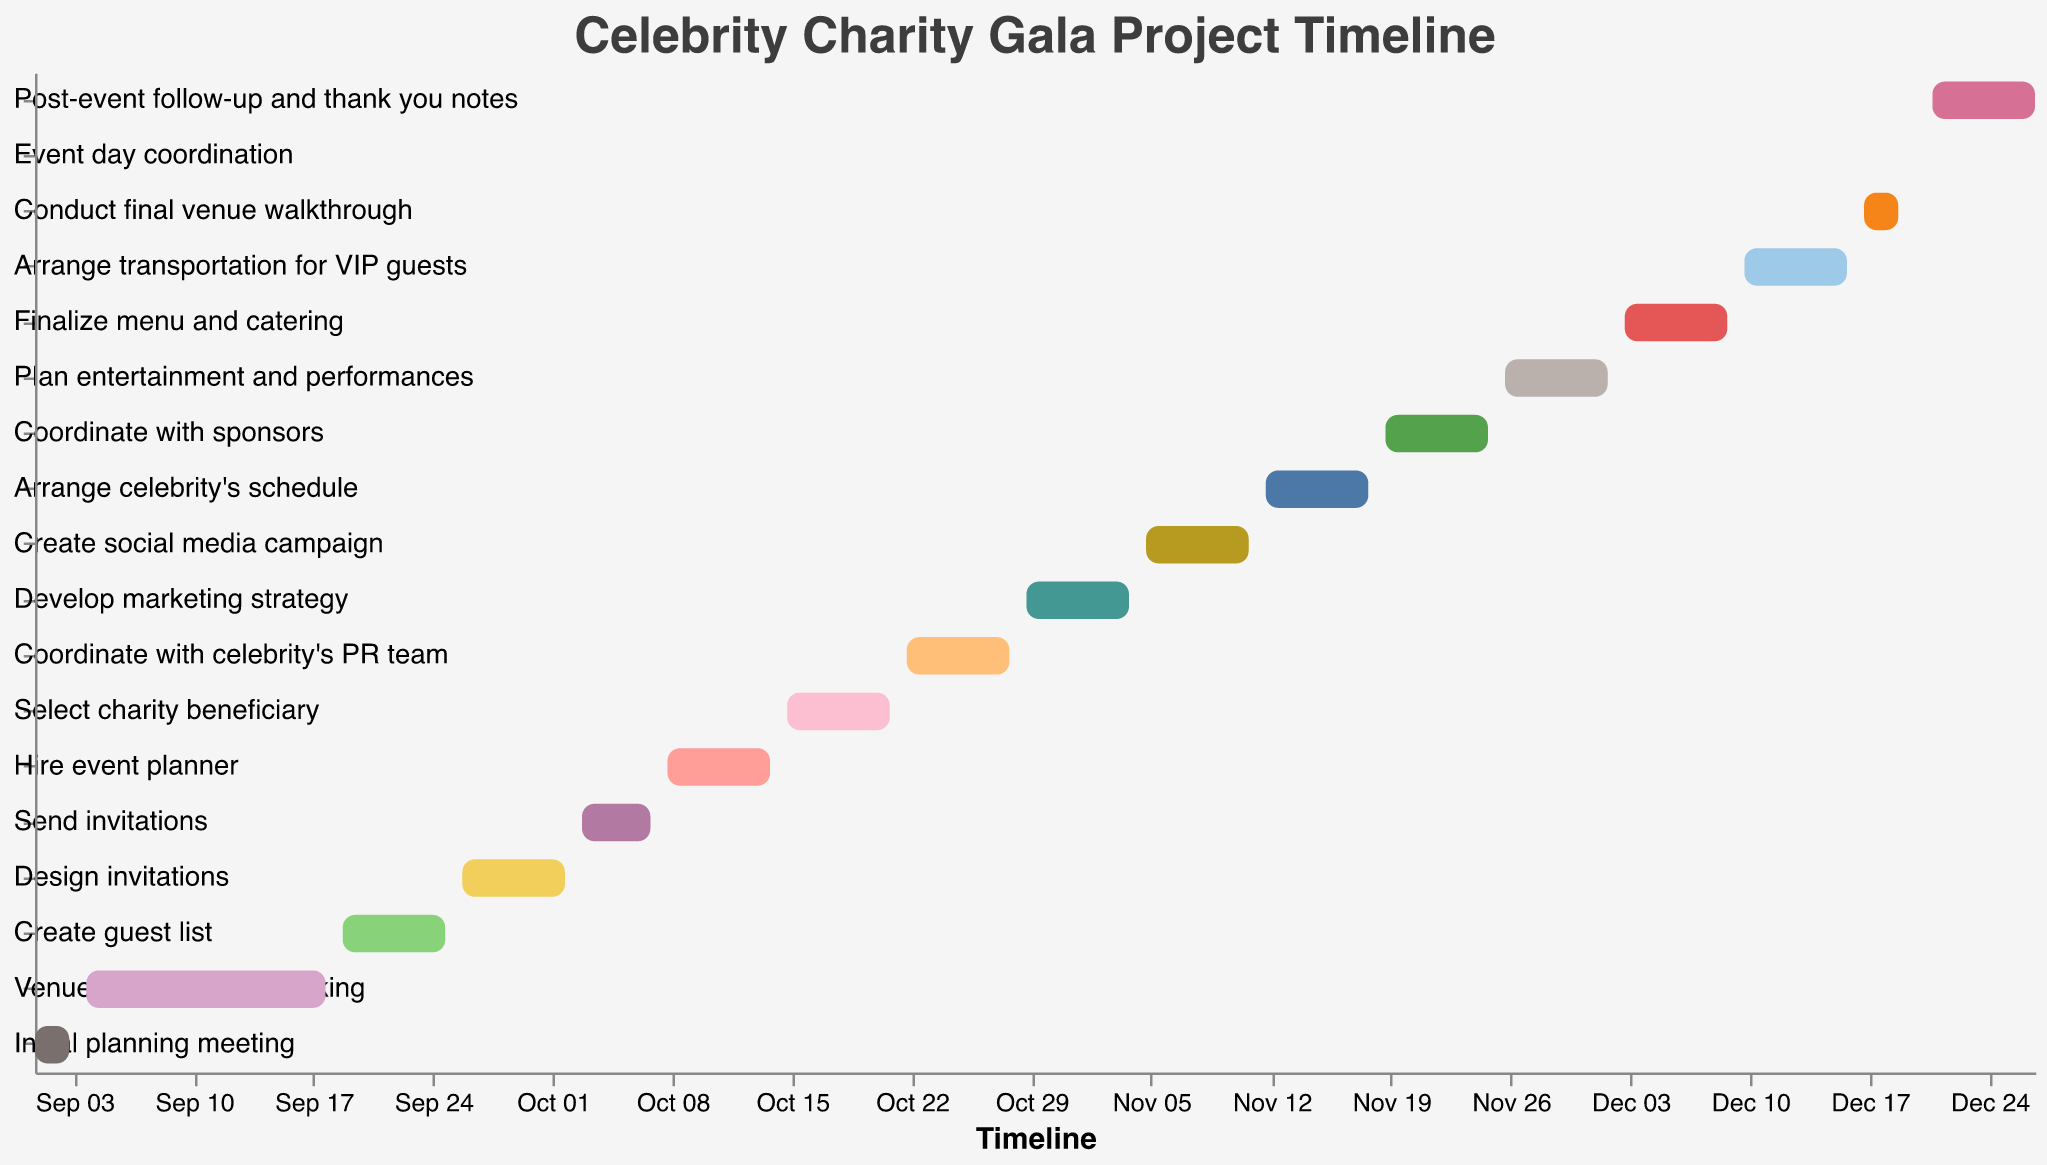What's the title of the chart? The title of the chart is typically found at the top of the figure and it summarises the purpose or content of the chart. In this case, the title is "Celebrity Charity Gala Project Timeline".
Answer: Celebrity Charity Gala Project Timeline How long does the "Venue selection and booking" task take? To determine the duration of the "Venue selection and booking" task, subtract the start date (2023-09-04) from the end date (2023-09-18). The difference is 14 days.
Answer: 14 days Which task starts first, "Create guest list" or "Design invitations"? By comparing the start dates of "Create guest list" (2023-09-19) and "Design invitations" (2023-09-26), it's evident that "Create guest list" starts first.
Answer: Create guest list What is the last task on the chart? The last task is determined by looking at the end dates of all tasks. The task "Post-event follow-up and thank you notes" ends on 2023-12-27, making it the last task.
Answer: Post-event follow-up and thank you notes During which month does the "Develop marketing strategy" task occur? The start date of the "Develop marketing strategy" task is 2023-10-29 and the end date is 2023-11-04. Both dates fall within October and November.
Answer: October and November Which tasks overlap with "Hire event planner"? To identify overlapping tasks, compare the duration of "Hire event planner" (2023-10-08 to 2023-10-14) with other tasks' durations. "Send invitations" (2023-10-03 to 2023-10-07) and "Select charity beneficiary" (2023-10-15 to 2023-10-21) slightly overlap with "Hire event planner".
Answer: None Name two tasks that happen solely in December. By examining tasks with both start and end dates in December, the tasks "Finalize menu and catering" (2023-12-03 to 2023-12-09) and "Arrange transportation for VIP guests" (2023-12-10 to 2023-12-16) are solely in December.
Answer: Finalize menu and catering, Arrange transportation for VIP guests Which phase has the most number of tasks? (Planning, Promotion, Execution) To determine this, categorize tasks into the phases: Planning (up to "Select charity beneficiary"), Promotion (up to "Create social media campaign"), and Execution (remaining tasks). The Promotion phase has the most number of tasks, totaling five.
Answer: Promotion Which task is shorter, "Create social media campaign" or "Plan entertainment and performances"? Compare the durations of "Create social media campaign" (2023-11-05 to 2023-11-11, 6 days) and "Plan entertainment and performances" (2023-11-26 to 2023-12-02, 6 days). Both tasks have the same duration.
Answer: Both have the same duration 